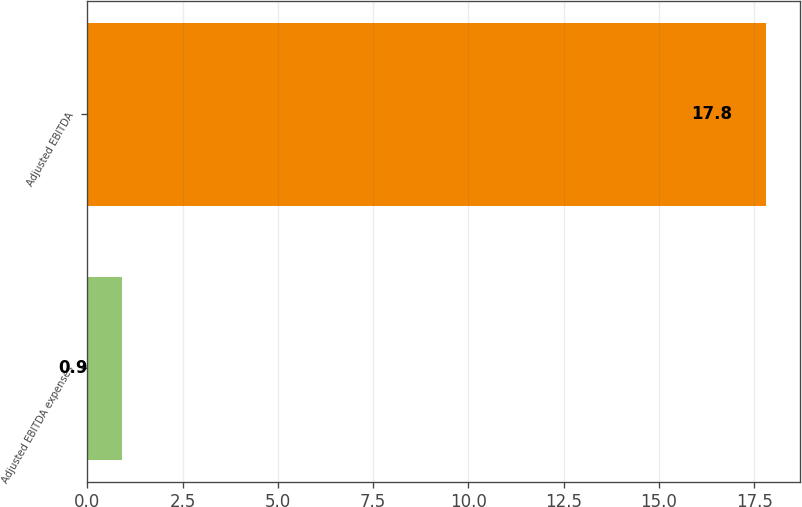<chart> <loc_0><loc_0><loc_500><loc_500><bar_chart><fcel>Adjusted EBITDA expenses<fcel>Adjusted EBITDA<nl><fcel>0.9<fcel>17.8<nl></chart> 